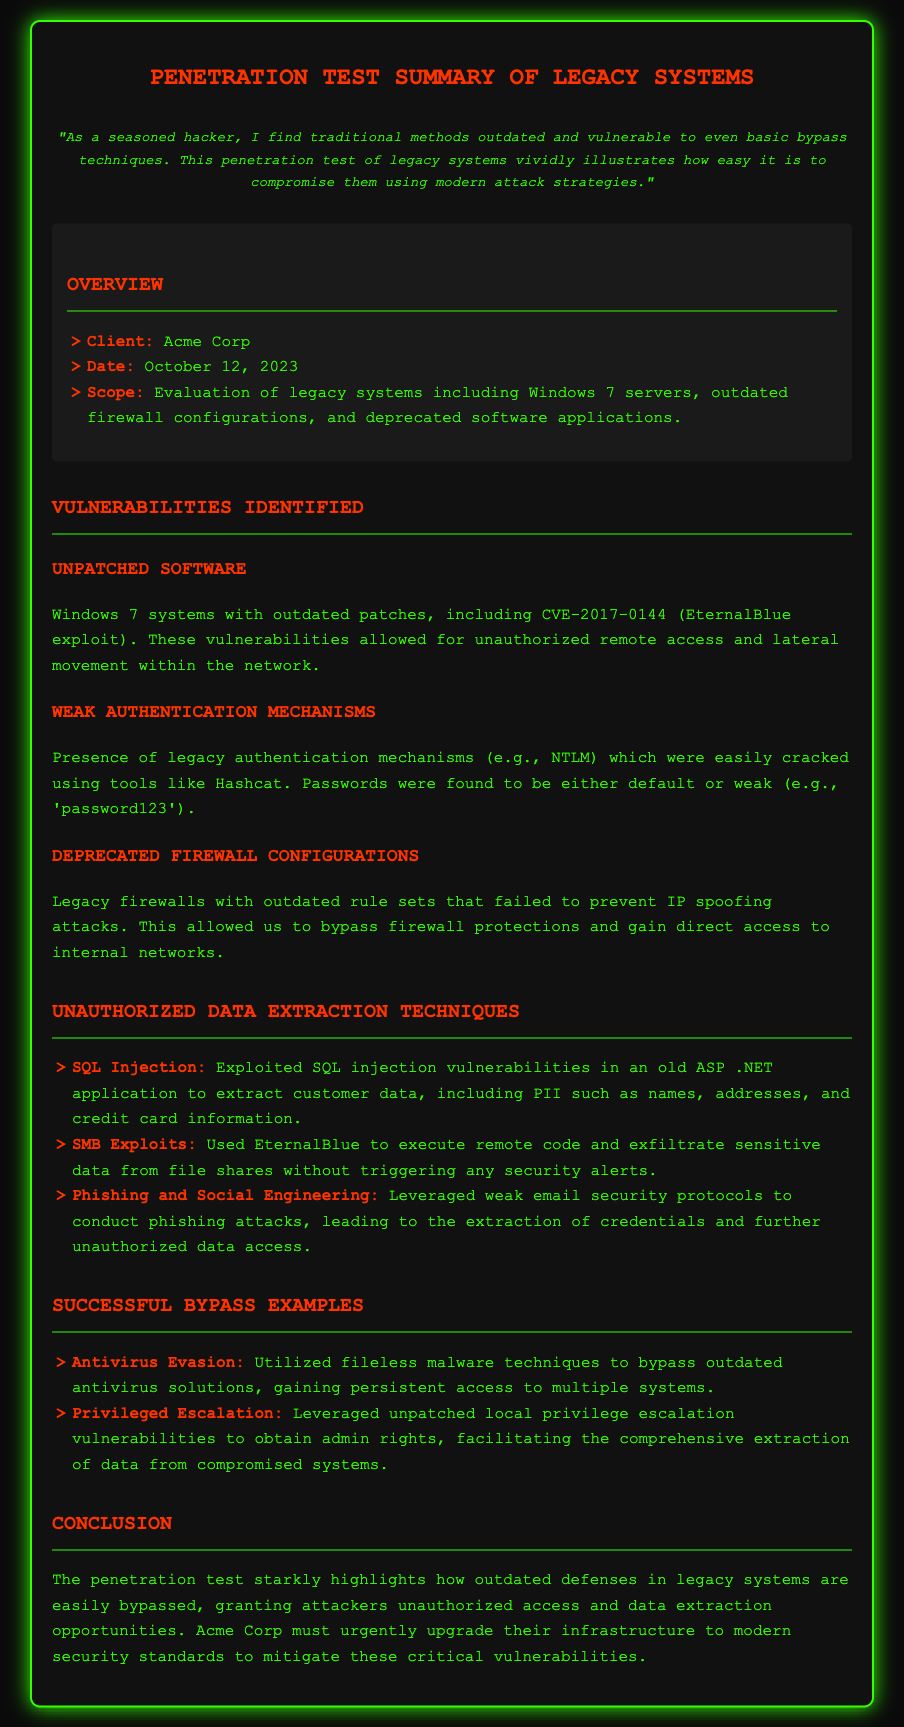what is the client name? The client's name is mentioned in the overview section of the document.
Answer: Acme Corp when was the penetration test conducted? The date of the penetration test is stated in the overview section.
Answer: October 12, 2023 what type of systems were evaluated in this penetration test? The scope specifies the types of systems included in the evaluation.
Answer: Legacy systems which vulnerability allowed unauthorized remote access? The document identifies a specific vulnerability linked to unauthorized remote access.
Answer: CVE-2017-0144 what technique was used to bypass outdated antivirus solutions? The successful bypass example identifies a specific technique used against antivirus software.
Answer: Fileless malware techniques which deprecated software authentication mechanism was mentioned? The identified weak authentication mechanism is described in the vulnerabilities section.
Answer: NTLM what was one of the unauthorized data extraction techniques? The document lists unauthorized techniques used for data extraction.
Answer: SQL Injection how was sensitive data exfiltrated without triggering alerts? The document describes a method that allowed data exfiltration stealthily.
Answer: EternalBlue 